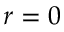Convert formula to latex. <formula><loc_0><loc_0><loc_500><loc_500>r = 0</formula> 